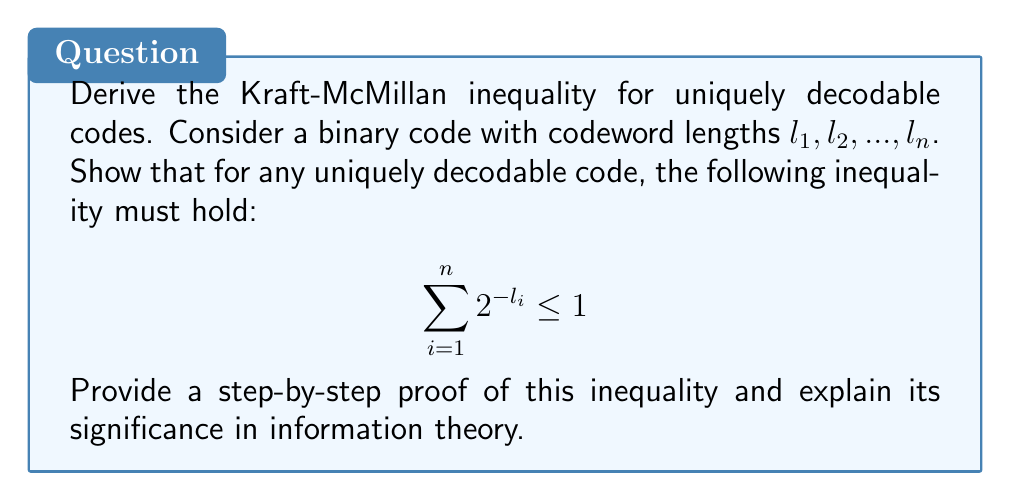Provide a solution to this math problem. Let's approach this proof step-by-step:

1) First, let's understand what uniquely decodable means. A code is uniquely decodable if any sequence of codewords can be decoded in only one way.

2) We'll use a technique called the Kraft series. For each codeword length $l_i$, consider the series:

   $$S = (2^{-l_1} + 2^{-l_2} + ... + 2^{-l_n})^m$$

   where $m$ is a positive integer.

3) Expand this series. Each term will be of the form $2^{-(k_1l_1 + k_2l_2 + ... + k_nl_n)}$, where $k_1 + k_2 + ... + k_n = m$.

4) Now, consider all possible binary strings of length $L = m \cdot \max(l_i)$. There are $2^L$ such strings.

5) Each term in the expanded Kraft series corresponds to a sequence of $m$ codewords. If the code is uniquely decodable, each of these sequences must correspond to a distinct binary string of length $L$ or less.

6) Therefore, the number of terms in the expanded series must be less than or equal to $2^L$:

   $$S = (2^{-l_1} + 2^{-l_2} + ... + 2^{-l_n})^m \leq 2^L = 2^{m \cdot \max(l_i)}$$

7) Taking the $m$-th root of both sides:

   $$2^{-l_1} + 2^{-l_2} + ... + 2^{-l_n} \leq 2^{\max(l_i)/m}$$

8) As $m$ approaches infinity, the right side approaches 1:

   $$\sum_{i=1}^n 2^{-l_i} \leq 1$$

This inequality is known as the Kraft-McMillan inequality. It's significant because it provides a necessary condition for the existence of a uniquely decodable code. Moreover, it's also a sufficient condition for the existence of a prefix-free code, which is always uniquely decodable.
Answer: $$\sum_{i=1}^n 2^{-l_i} \leq 1$$ 